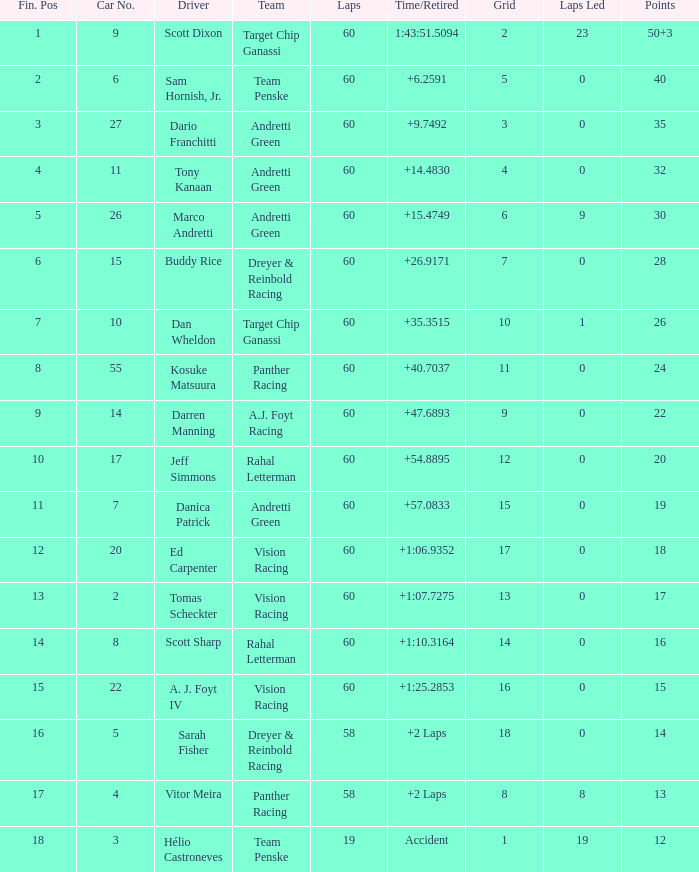List the laps that are equivalent to 18 points. 60.0. 